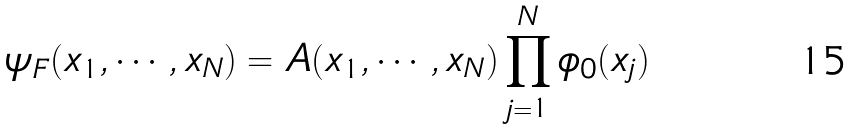<formula> <loc_0><loc_0><loc_500><loc_500>\psi _ { F } ( x _ { 1 } , \cdots , x _ { N } ) = A ( x _ { 1 } , \cdots , x _ { N } ) \prod _ { j = 1 } ^ { N } \phi _ { 0 } ( x _ { j } )</formula> 